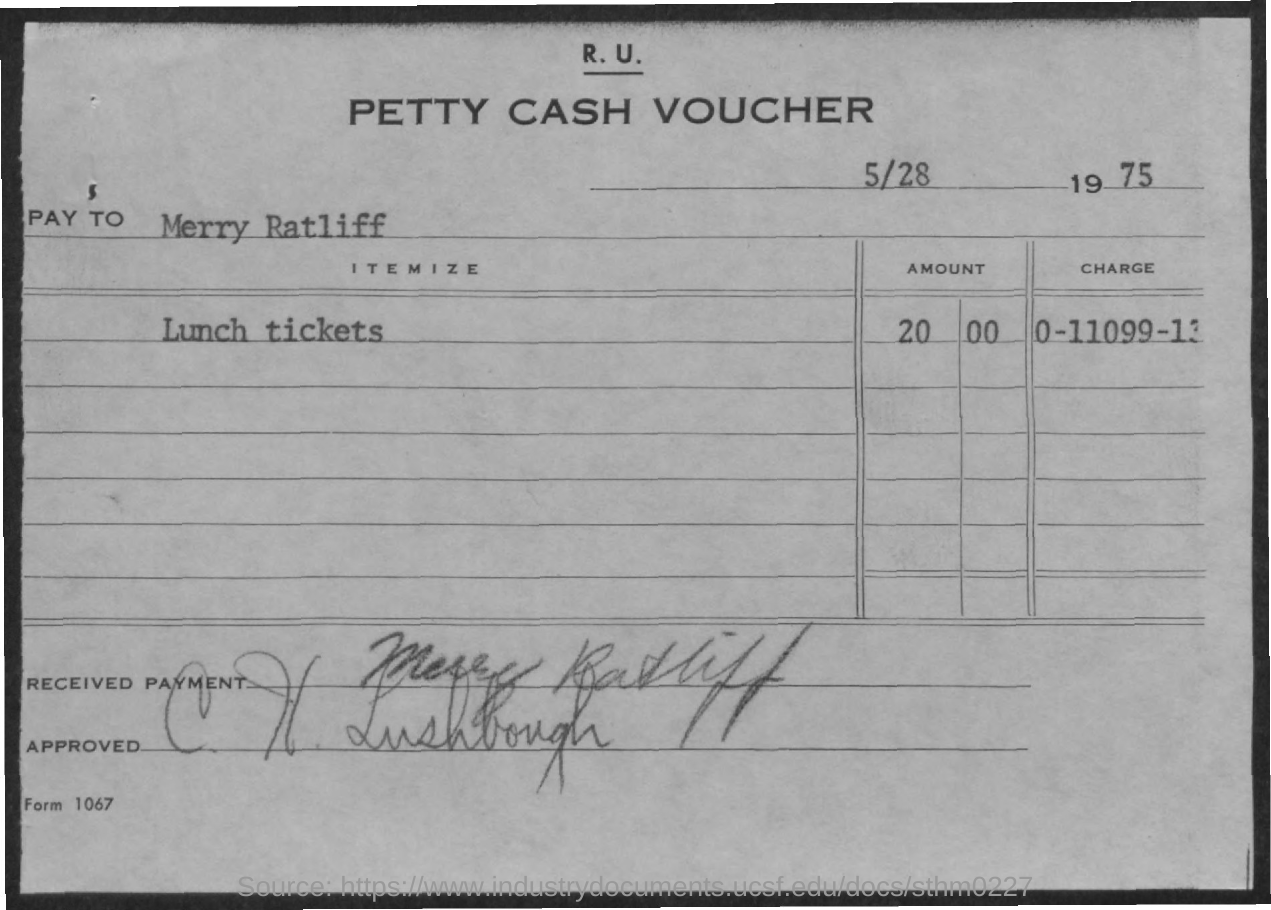Draw attention to some important aspects in this diagram. The charge number mentioned in the voucher is 0-11099-13. The voucher mentions Merry Ratliff as the name provided by the payee. The voucher mentions 20,000 lunch tickets. 